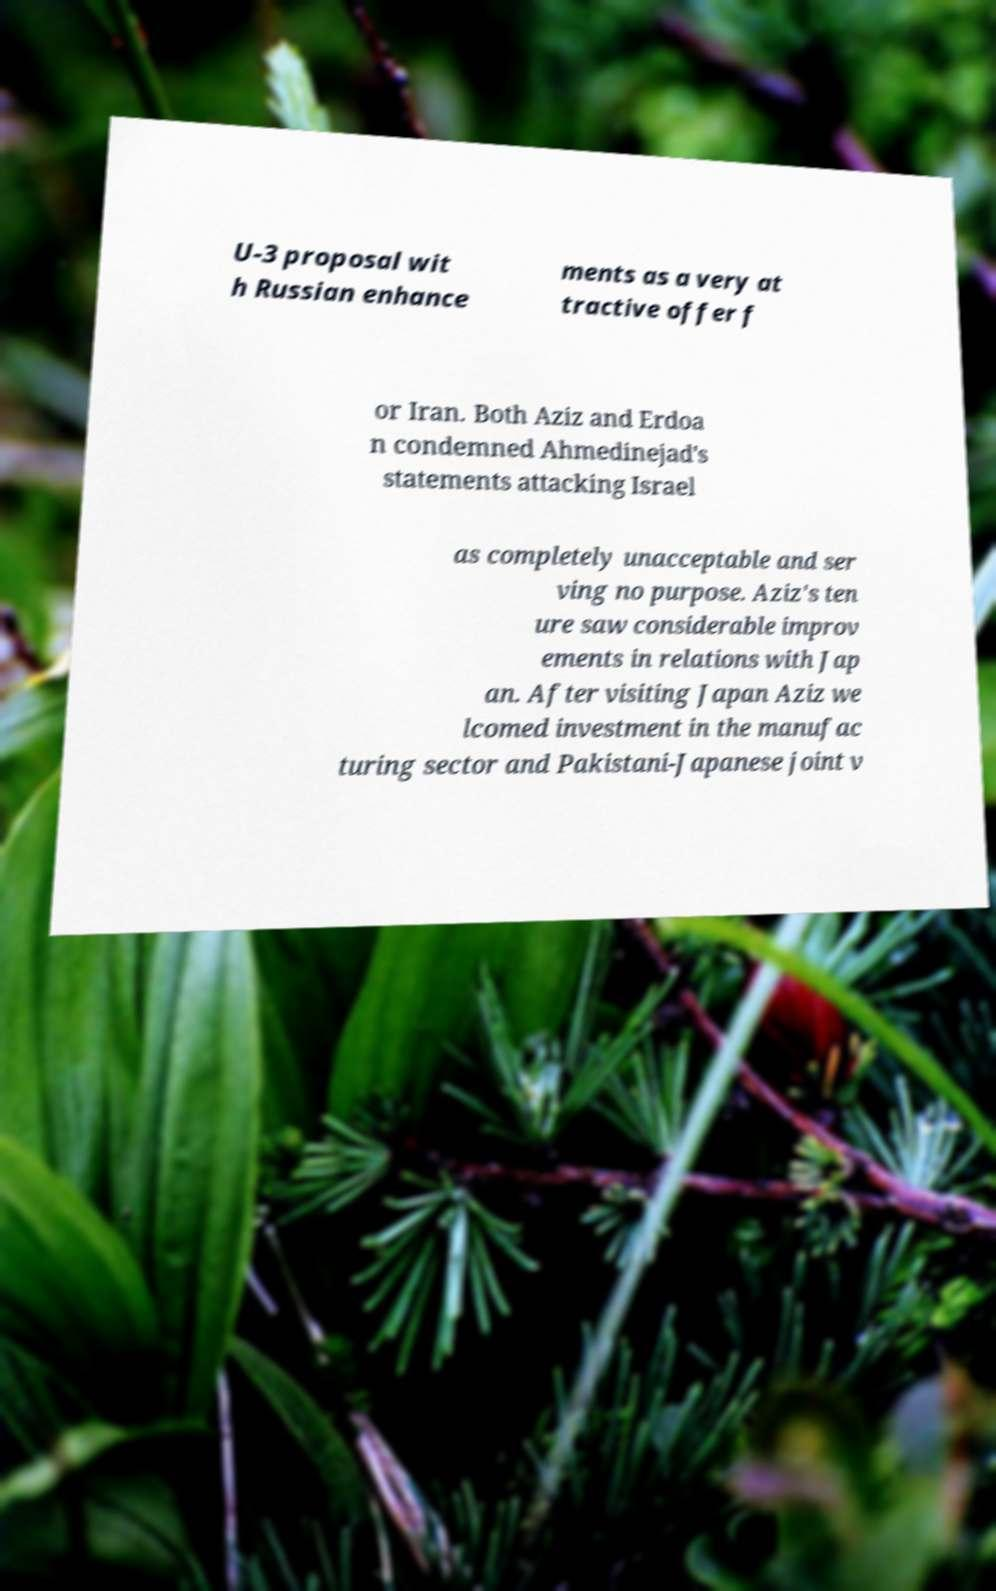For documentation purposes, I need the text within this image transcribed. Could you provide that? U-3 proposal wit h Russian enhance ments as a very at tractive offer f or Iran. Both Aziz and Erdoa n condemned Ahmedinejad's statements attacking Israel as completely unacceptable and ser ving no purpose. Aziz's ten ure saw considerable improv ements in relations with Jap an. After visiting Japan Aziz we lcomed investment in the manufac turing sector and Pakistani-Japanese joint v 